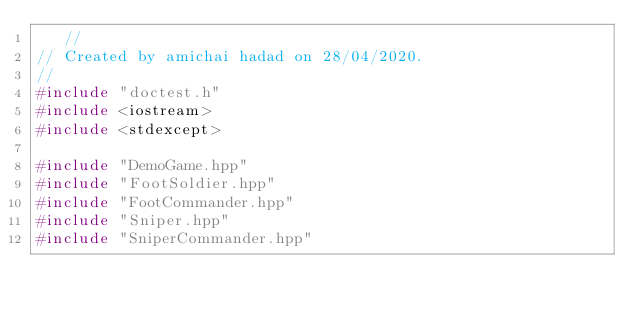<code> <loc_0><loc_0><loc_500><loc_500><_C++_>	 //
// Created by amichai hadad on 28/04/2020.
//
#include "doctest.h"
#include <iostream>
#include <stdexcept>

#include "DemoGame.hpp"
#include "FootSoldier.hpp"
#include "FootCommander.hpp"
#include "Sniper.hpp"
#include "SniperCommander.hpp"</code> 